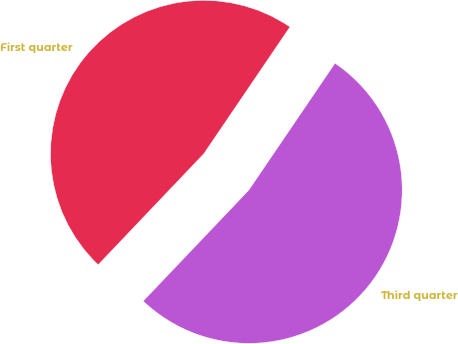<chart> <loc_0><loc_0><loc_500><loc_500><pie_chart><fcel>First quarter<fcel>Third quarter<nl><fcel>47.39%<fcel>52.61%<nl></chart> 